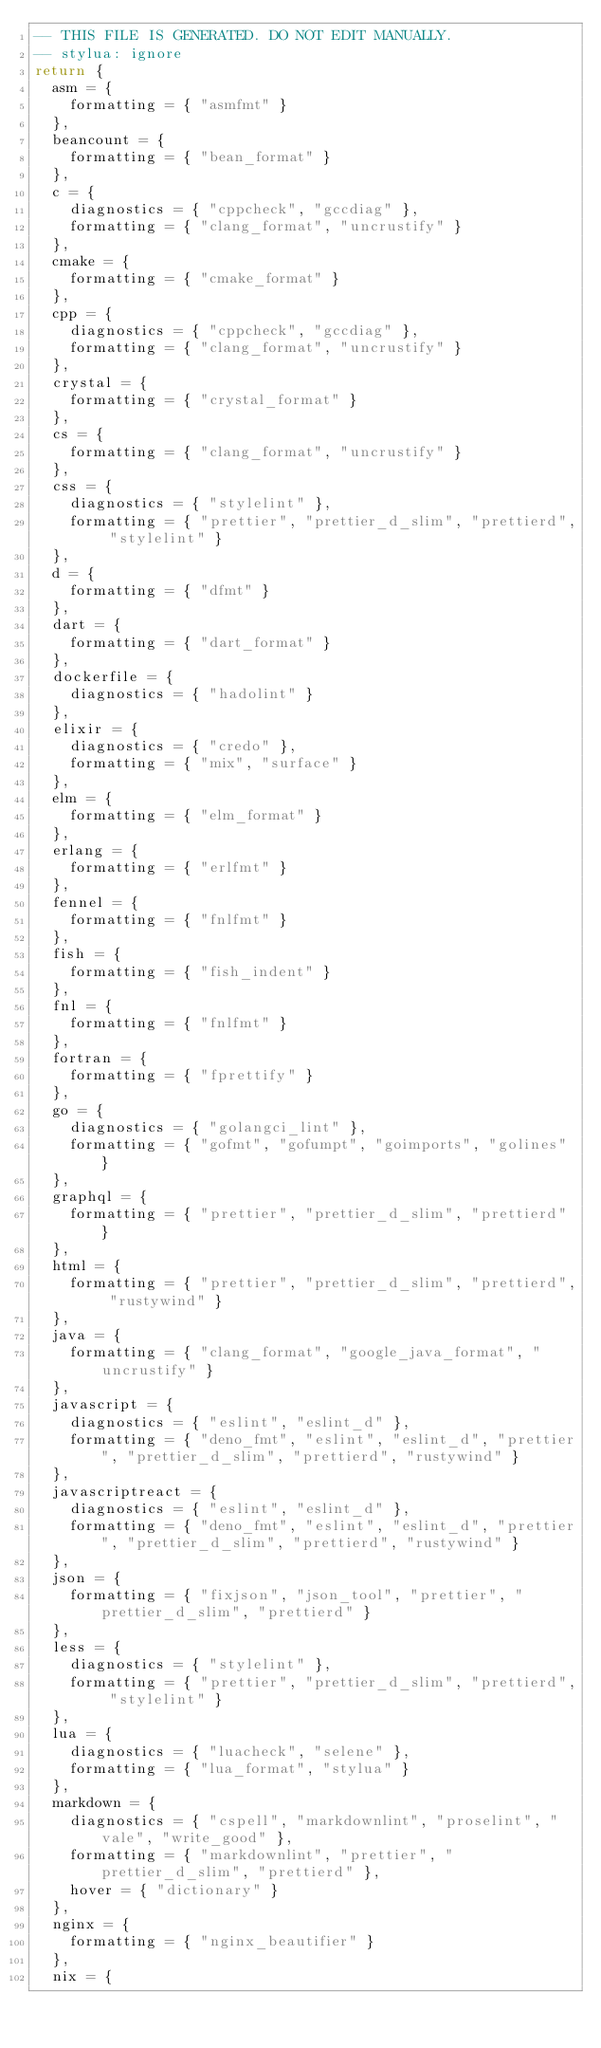Convert code to text. <code><loc_0><loc_0><loc_500><loc_500><_Lua_>-- THIS FILE IS GENERATED. DO NOT EDIT MANUALLY.
-- stylua: ignore
return {
  asm = {
    formatting = { "asmfmt" }
  },
  beancount = {
    formatting = { "bean_format" }
  },
  c = {
    diagnostics = { "cppcheck", "gccdiag" },
    formatting = { "clang_format", "uncrustify" }
  },
  cmake = {
    formatting = { "cmake_format" }
  },
  cpp = {
    diagnostics = { "cppcheck", "gccdiag" },
    formatting = { "clang_format", "uncrustify" }
  },
  crystal = {
    formatting = { "crystal_format" }
  },
  cs = {
    formatting = { "clang_format", "uncrustify" }
  },
  css = {
    diagnostics = { "stylelint" },
    formatting = { "prettier", "prettier_d_slim", "prettierd", "stylelint" }
  },
  d = {
    formatting = { "dfmt" }
  },
  dart = {
    formatting = { "dart_format" }
  },
  dockerfile = {
    diagnostics = { "hadolint" }
  },
  elixir = {
    diagnostics = { "credo" },
    formatting = { "mix", "surface" }
  },
  elm = {
    formatting = { "elm_format" }
  },
  erlang = {
    formatting = { "erlfmt" }
  },
  fennel = {
    formatting = { "fnlfmt" }
  },
  fish = {
    formatting = { "fish_indent" }
  },
  fnl = {
    formatting = { "fnlfmt" }
  },
  fortran = {
    formatting = { "fprettify" }
  },
  go = {
    diagnostics = { "golangci_lint" },
    formatting = { "gofmt", "gofumpt", "goimports", "golines" }
  },
  graphql = {
    formatting = { "prettier", "prettier_d_slim", "prettierd" }
  },
  html = {
    formatting = { "prettier", "prettier_d_slim", "prettierd", "rustywind" }
  },
  java = {
    formatting = { "clang_format", "google_java_format", "uncrustify" }
  },
  javascript = {
    diagnostics = { "eslint", "eslint_d" },
    formatting = { "deno_fmt", "eslint", "eslint_d", "prettier", "prettier_d_slim", "prettierd", "rustywind" }
  },
  javascriptreact = {
    diagnostics = { "eslint", "eslint_d" },
    formatting = { "deno_fmt", "eslint", "eslint_d", "prettier", "prettier_d_slim", "prettierd", "rustywind" }
  },
  json = {
    formatting = { "fixjson", "json_tool", "prettier", "prettier_d_slim", "prettierd" }
  },
  less = {
    diagnostics = { "stylelint" },
    formatting = { "prettier", "prettier_d_slim", "prettierd", "stylelint" }
  },
  lua = {
    diagnostics = { "luacheck", "selene" },
    formatting = { "lua_format", "stylua" }
  },
  markdown = {
    diagnostics = { "cspell", "markdownlint", "proselint", "vale", "write_good" },
    formatting = { "markdownlint", "prettier", "prettier_d_slim", "prettierd" },
    hover = { "dictionary" }
  },
  nginx = {
    formatting = { "nginx_beautifier" }
  },
  nix = {</code> 